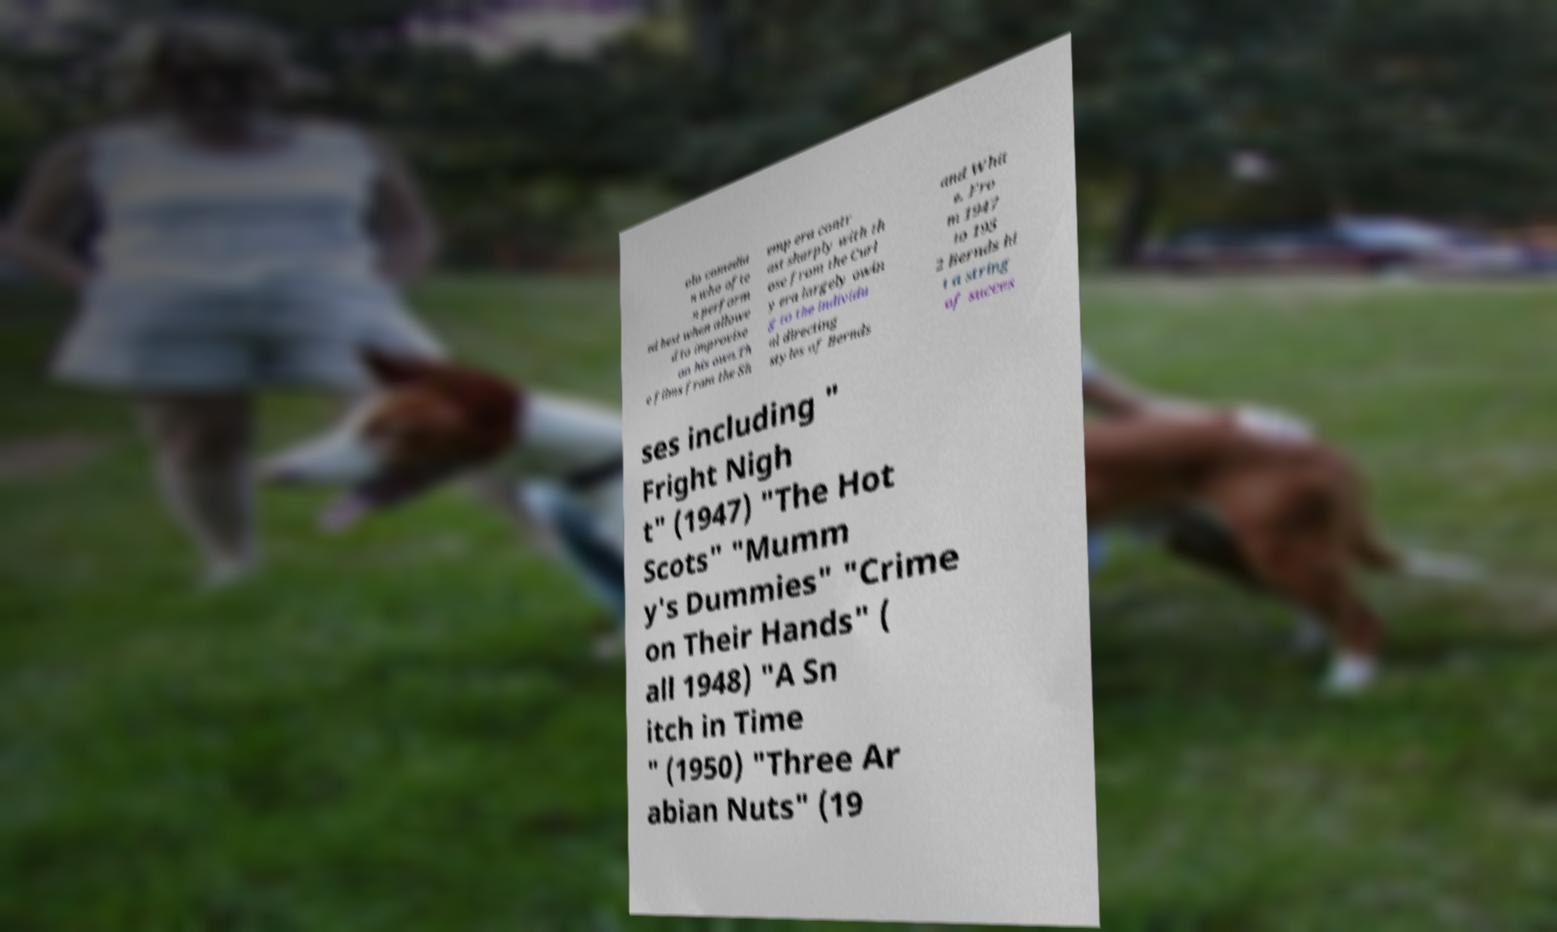Could you assist in decoding the text presented in this image and type it out clearly? olo comedia n who ofte n perform ed best when allowe d to improvise on his own.Th e films from the Sh emp era contr ast sharply with th ose from the Curl y era largely owin g to the individu al directing styles of Bernds and Whit e. Fro m 1947 to 195 2 Bernds hi t a string of succes ses including " Fright Nigh t" (1947) "The Hot Scots" "Mumm y's Dummies" "Crime on Their Hands" ( all 1948) "A Sn itch in Time " (1950) "Three Ar abian Nuts" (19 